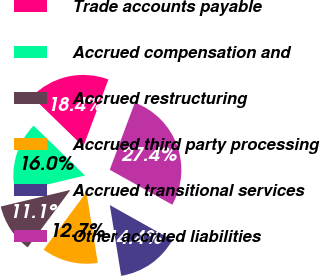Convert chart to OTSL. <chart><loc_0><loc_0><loc_500><loc_500><pie_chart><fcel>Trade accounts payable<fcel>Accrued compensation and<fcel>Accrued restructuring<fcel>Accrued third party processing<fcel>Accrued transitional services<fcel>Other accrued liabilities<nl><fcel>18.43%<fcel>15.99%<fcel>11.09%<fcel>12.72%<fcel>14.36%<fcel>27.41%<nl></chart> 